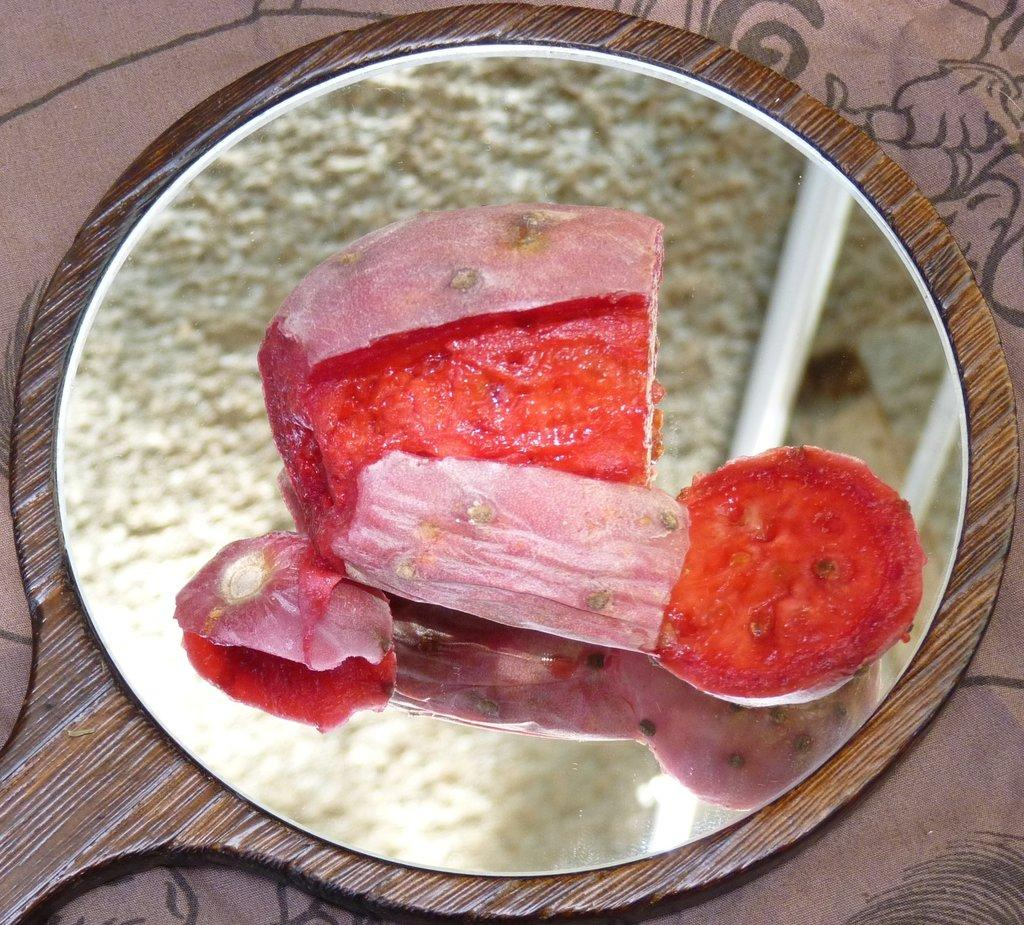What is the main subject of the image? The main subject of the image is a food item on a pan. Where is the pan located in the image? The pan is on a table in the image. What type of argument is taking place between the food items in the image? There is no argument taking place between the food items in the image, as they are inanimate objects. 